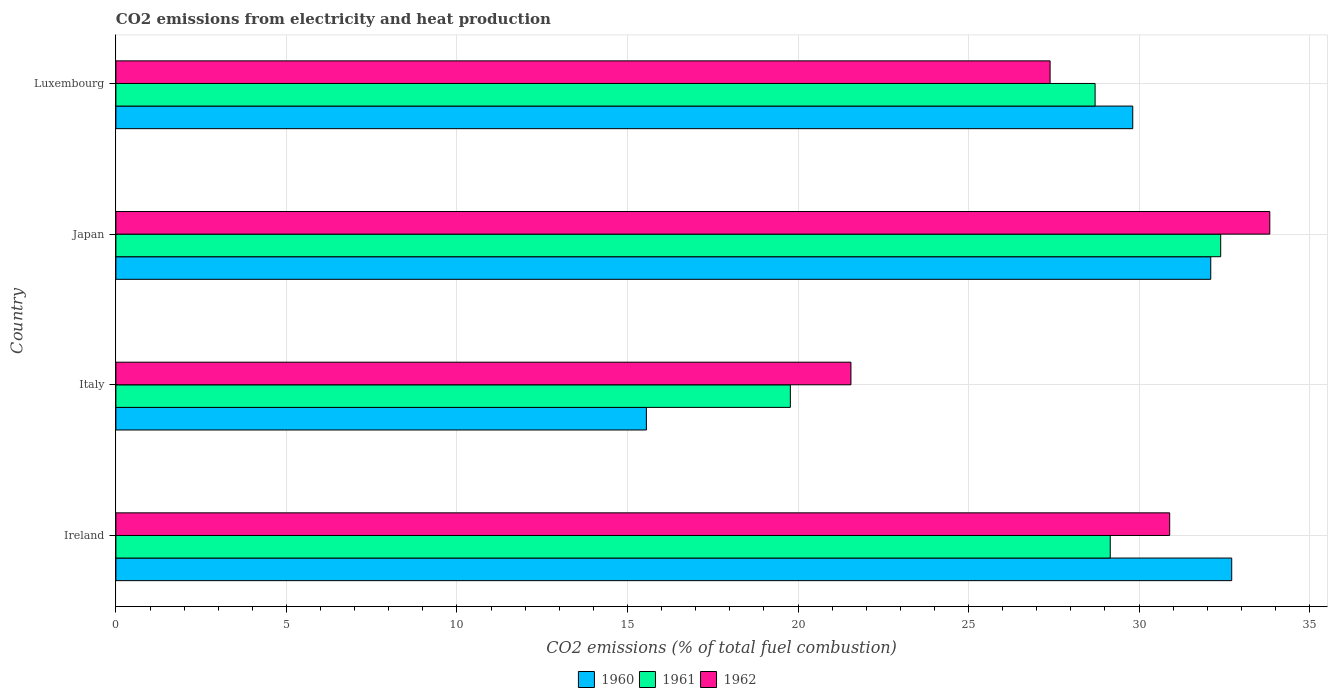How many different coloured bars are there?
Provide a succinct answer. 3. How many groups of bars are there?
Provide a succinct answer. 4. How many bars are there on the 4th tick from the top?
Offer a very short reply. 3. How many bars are there on the 1st tick from the bottom?
Provide a succinct answer. 3. In how many cases, is the number of bars for a given country not equal to the number of legend labels?
Offer a terse response. 0. What is the amount of CO2 emitted in 1961 in Italy?
Your response must be concise. 19.78. Across all countries, what is the maximum amount of CO2 emitted in 1960?
Provide a short and direct response. 32.72. Across all countries, what is the minimum amount of CO2 emitted in 1962?
Your response must be concise. 21.55. In which country was the amount of CO2 emitted in 1961 maximum?
Keep it short and to the point. Japan. In which country was the amount of CO2 emitted in 1960 minimum?
Make the answer very short. Italy. What is the total amount of CO2 emitted in 1962 in the graph?
Your response must be concise. 113.67. What is the difference between the amount of CO2 emitted in 1962 in Italy and that in Japan?
Provide a succinct answer. -12.28. What is the difference between the amount of CO2 emitted in 1961 in Luxembourg and the amount of CO2 emitted in 1960 in Ireland?
Offer a terse response. -4.01. What is the average amount of CO2 emitted in 1961 per country?
Your answer should be very brief. 27.51. What is the difference between the amount of CO2 emitted in 1961 and amount of CO2 emitted in 1962 in Japan?
Ensure brevity in your answer.  -1.44. In how many countries, is the amount of CO2 emitted in 1961 greater than 21 %?
Offer a terse response. 3. What is the ratio of the amount of CO2 emitted in 1961 in Ireland to that in Luxembourg?
Provide a short and direct response. 1.02. Is the difference between the amount of CO2 emitted in 1961 in Ireland and Italy greater than the difference between the amount of CO2 emitted in 1962 in Ireland and Italy?
Make the answer very short. Yes. What is the difference between the highest and the second highest amount of CO2 emitted in 1962?
Offer a terse response. 2.94. What is the difference between the highest and the lowest amount of CO2 emitted in 1961?
Provide a succinct answer. 12.62. Is the sum of the amount of CO2 emitted in 1961 in Japan and Luxembourg greater than the maximum amount of CO2 emitted in 1962 across all countries?
Your answer should be compact. Yes. What does the 2nd bar from the top in Japan represents?
Your answer should be compact. 1961. What does the 2nd bar from the bottom in Ireland represents?
Ensure brevity in your answer.  1961. Are all the bars in the graph horizontal?
Provide a succinct answer. Yes. How many countries are there in the graph?
Make the answer very short. 4. What is the difference between two consecutive major ticks on the X-axis?
Ensure brevity in your answer.  5. Does the graph contain any zero values?
Your response must be concise. No. Where does the legend appear in the graph?
Your response must be concise. Bottom center. What is the title of the graph?
Offer a terse response. CO2 emissions from electricity and heat production. What is the label or title of the X-axis?
Offer a very short reply. CO2 emissions (% of total fuel combustion). What is the CO2 emissions (% of total fuel combustion) of 1960 in Ireland?
Offer a very short reply. 32.72. What is the CO2 emissions (% of total fuel combustion) of 1961 in Ireland?
Your response must be concise. 29.15. What is the CO2 emissions (% of total fuel combustion) in 1962 in Ireland?
Ensure brevity in your answer.  30.9. What is the CO2 emissions (% of total fuel combustion) in 1960 in Italy?
Offer a terse response. 15.55. What is the CO2 emissions (% of total fuel combustion) of 1961 in Italy?
Provide a succinct answer. 19.78. What is the CO2 emissions (% of total fuel combustion) of 1962 in Italy?
Provide a short and direct response. 21.55. What is the CO2 emissions (% of total fuel combustion) in 1960 in Japan?
Offer a terse response. 32.1. What is the CO2 emissions (% of total fuel combustion) in 1961 in Japan?
Give a very brief answer. 32.39. What is the CO2 emissions (% of total fuel combustion) in 1962 in Japan?
Give a very brief answer. 33.83. What is the CO2 emissions (% of total fuel combustion) of 1960 in Luxembourg?
Make the answer very short. 29.81. What is the CO2 emissions (% of total fuel combustion) in 1961 in Luxembourg?
Ensure brevity in your answer.  28.71. What is the CO2 emissions (% of total fuel combustion) of 1962 in Luxembourg?
Give a very brief answer. 27.39. Across all countries, what is the maximum CO2 emissions (% of total fuel combustion) in 1960?
Offer a very short reply. 32.72. Across all countries, what is the maximum CO2 emissions (% of total fuel combustion) in 1961?
Provide a succinct answer. 32.39. Across all countries, what is the maximum CO2 emissions (% of total fuel combustion) in 1962?
Offer a very short reply. 33.83. Across all countries, what is the minimum CO2 emissions (% of total fuel combustion) in 1960?
Make the answer very short. 15.55. Across all countries, what is the minimum CO2 emissions (% of total fuel combustion) of 1961?
Your response must be concise. 19.78. Across all countries, what is the minimum CO2 emissions (% of total fuel combustion) of 1962?
Offer a very short reply. 21.55. What is the total CO2 emissions (% of total fuel combustion) in 1960 in the graph?
Your response must be concise. 110.19. What is the total CO2 emissions (% of total fuel combustion) in 1961 in the graph?
Your answer should be compact. 110.03. What is the total CO2 emissions (% of total fuel combustion) of 1962 in the graph?
Keep it short and to the point. 113.67. What is the difference between the CO2 emissions (% of total fuel combustion) of 1960 in Ireland and that in Italy?
Make the answer very short. 17.16. What is the difference between the CO2 emissions (% of total fuel combustion) in 1961 in Ireland and that in Italy?
Give a very brief answer. 9.38. What is the difference between the CO2 emissions (% of total fuel combustion) of 1962 in Ireland and that in Italy?
Offer a very short reply. 9.35. What is the difference between the CO2 emissions (% of total fuel combustion) in 1960 in Ireland and that in Japan?
Make the answer very short. 0.61. What is the difference between the CO2 emissions (% of total fuel combustion) in 1961 in Ireland and that in Japan?
Ensure brevity in your answer.  -3.24. What is the difference between the CO2 emissions (% of total fuel combustion) in 1962 in Ireland and that in Japan?
Offer a terse response. -2.94. What is the difference between the CO2 emissions (% of total fuel combustion) in 1960 in Ireland and that in Luxembourg?
Provide a short and direct response. 2.9. What is the difference between the CO2 emissions (% of total fuel combustion) in 1961 in Ireland and that in Luxembourg?
Provide a succinct answer. 0.44. What is the difference between the CO2 emissions (% of total fuel combustion) in 1962 in Ireland and that in Luxembourg?
Your response must be concise. 3.51. What is the difference between the CO2 emissions (% of total fuel combustion) in 1960 in Italy and that in Japan?
Your response must be concise. -16.55. What is the difference between the CO2 emissions (% of total fuel combustion) of 1961 in Italy and that in Japan?
Your response must be concise. -12.62. What is the difference between the CO2 emissions (% of total fuel combustion) in 1962 in Italy and that in Japan?
Keep it short and to the point. -12.28. What is the difference between the CO2 emissions (% of total fuel combustion) in 1960 in Italy and that in Luxembourg?
Give a very brief answer. -14.26. What is the difference between the CO2 emissions (% of total fuel combustion) in 1961 in Italy and that in Luxembourg?
Make the answer very short. -8.93. What is the difference between the CO2 emissions (% of total fuel combustion) of 1962 in Italy and that in Luxembourg?
Offer a terse response. -5.84. What is the difference between the CO2 emissions (% of total fuel combustion) of 1960 in Japan and that in Luxembourg?
Provide a short and direct response. 2.29. What is the difference between the CO2 emissions (% of total fuel combustion) of 1961 in Japan and that in Luxembourg?
Provide a succinct answer. 3.68. What is the difference between the CO2 emissions (% of total fuel combustion) in 1962 in Japan and that in Luxembourg?
Provide a short and direct response. 6.44. What is the difference between the CO2 emissions (% of total fuel combustion) of 1960 in Ireland and the CO2 emissions (% of total fuel combustion) of 1961 in Italy?
Your answer should be very brief. 12.94. What is the difference between the CO2 emissions (% of total fuel combustion) in 1960 in Ireland and the CO2 emissions (% of total fuel combustion) in 1962 in Italy?
Offer a terse response. 11.16. What is the difference between the CO2 emissions (% of total fuel combustion) in 1961 in Ireland and the CO2 emissions (% of total fuel combustion) in 1962 in Italy?
Give a very brief answer. 7.6. What is the difference between the CO2 emissions (% of total fuel combustion) of 1960 in Ireland and the CO2 emissions (% of total fuel combustion) of 1961 in Japan?
Your response must be concise. 0.32. What is the difference between the CO2 emissions (% of total fuel combustion) of 1960 in Ireland and the CO2 emissions (% of total fuel combustion) of 1962 in Japan?
Your answer should be compact. -1.12. What is the difference between the CO2 emissions (% of total fuel combustion) in 1961 in Ireland and the CO2 emissions (% of total fuel combustion) in 1962 in Japan?
Make the answer very short. -4.68. What is the difference between the CO2 emissions (% of total fuel combustion) in 1960 in Ireland and the CO2 emissions (% of total fuel combustion) in 1961 in Luxembourg?
Your answer should be compact. 4.01. What is the difference between the CO2 emissions (% of total fuel combustion) of 1960 in Ireland and the CO2 emissions (% of total fuel combustion) of 1962 in Luxembourg?
Offer a terse response. 5.33. What is the difference between the CO2 emissions (% of total fuel combustion) of 1961 in Ireland and the CO2 emissions (% of total fuel combustion) of 1962 in Luxembourg?
Offer a very short reply. 1.76. What is the difference between the CO2 emissions (% of total fuel combustion) of 1960 in Italy and the CO2 emissions (% of total fuel combustion) of 1961 in Japan?
Make the answer very short. -16.84. What is the difference between the CO2 emissions (% of total fuel combustion) of 1960 in Italy and the CO2 emissions (% of total fuel combustion) of 1962 in Japan?
Offer a terse response. -18.28. What is the difference between the CO2 emissions (% of total fuel combustion) of 1961 in Italy and the CO2 emissions (% of total fuel combustion) of 1962 in Japan?
Offer a terse response. -14.06. What is the difference between the CO2 emissions (% of total fuel combustion) of 1960 in Italy and the CO2 emissions (% of total fuel combustion) of 1961 in Luxembourg?
Give a very brief answer. -13.16. What is the difference between the CO2 emissions (% of total fuel combustion) of 1960 in Italy and the CO2 emissions (% of total fuel combustion) of 1962 in Luxembourg?
Offer a terse response. -11.84. What is the difference between the CO2 emissions (% of total fuel combustion) in 1961 in Italy and the CO2 emissions (% of total fuel combustion) in 1962 in Luxembourg?
Provide a short and direct response. -7.62. What is the difference between the CO2 emissions (% of total fuel combustion) in 1960 in Japan and the CO2 emissions (% of total fuel combustion) in 1961 in Luxembourg?
Your answer should be compact. 3.39. What is the difference between the CO2 emissions (% of total fuel combustion) of 1960 in Japan and the CO2 emissions (% of total fuel combustion) of 1962 in Luxembourg?
Your response must be concise. 4.71. What is the difference between the CO2 emissions (% of total fuel combustion) in 1961 in Japan and the CO2 emissions (% of total fuel combustion) in 1962 in Luxembourg?
Make the answer very short. 5. What is the average CO2 emissions (% of total fuel combustion) in 1960 per country?
Provide a short and direct response. 27.55. What is the average CO2 emissions (% of total fuel combustion) in 1961 per country?
Your answer should be very brief. 27.51. What is the average CO2 emissions (% of total fuel combustion) in 1962 per country?
Ensure brevity in your answer.  28.42. What is the difference between the CO2 emissions (% of total fuel combustion) in 1960 and CO2 emissions (% of total fuel combustion) in 1961 in Ireland?
Provide a short and direct response. 3.56. What is the difference between the CO2 emissions (% of total fuel combustion) in 1960 and CO2 emissions (% of total fuel combustion) in 1962 in Ireland?
Your answer should be compact. 1.82. What is the difference between the CO2 emissions (% of total fuel combustion) in 1961 and CO2 emissions (% of total fuel combustion) in 1962 in Ireland?
Provide a succinct answer. -1.74. What is the difference between the CO2 emissions (% of total fuel combustion) of 1960 and CO2 emissions (% of total fuel combustion) of 1961 in Italy?
Your answer should be very brief. -4.22. What is the difference between the CO2 emissions (% of total fuel combustion) in 1960 and CO2 emissions (% of total fuel combustion) in 1962 in Italy?
Keep it short and to the point. -6. What is the difference between the CO2 emissions (% of total fuel combustion) in 1961 and CO2 emissions (% of total fuel combustion) in 1962 in Italy?
Offer a terse response. -1.78. What is the difference between the CO2 emissions (% of total fuel combustion) of 1960 and CO2 emissions (% of total fuel combustion) of 1961 in Japan?
Provide a short and direct response. -0.29. What is the difference between the CO2 emissions (% of total fuel combustion) in 1960 and CO2 emissions (% of total fuel combustion) in 1962 in Japan?
Your response must be concise. -1.73. What is the difference between the CO2 emissions (% of total fuel combustion) of 1961 and CO2 emissions (% of total fuel combustion) of 1962 in Japan?
Offer a very short reply. -1.44. What is the difference between the CO2 emissions (% of total fuel combustion) in 1960 and CO2 emissions (% of total fuel combustion) in 1961 in Luxembourg?
Your response must be concise. 1.1. What is the difference between the CO2 emissions (% of total fuel combustion) in 1960 and CO2 emissions (% of total fuel combustion) in 1962 in Luxembourg?
Your answer should be compact. 2.42. What is the difference between the CO2 emissions (% of total fuel combustion) in 1961 and CO2 emissions (% of total fuel combustion) in 1962 in Luxembourg?
Offer a terse response. 1.32. What is the ratio of the CO2 emissions (% of total fuel combustion) of 1960 in Ireland to that in Italy?
Ensure brevity in your answer.  2.1. What is the ratio of the CO2 emissions (% of total fuel combustion) of 1961 in Ireland to that in Italy?
Give a very brief answer. 1.47. What is the ratio of the CO2 emissions (% of total fuel combustion) of 1962 in Ireland to that in Italy?
Your answer should be compact. 1.43. What is the ratio of the CO2 emissions (% of total fuel combustion) of 1960 in Ireland to that in Japan?
Make the answer very short. 1.02. What is the ratio of the CO2 emissions (% of total fuel combustion) of 1962 in Ireland to that in Japan?
Your response must be concise. 0.91. What is the ratio of the CO2 emissions (% of total fuel combustion) of 1960 in Ireland to that in Luxembourg?
Make the answer very short. 1.1. What is the ratio of the CO2 emissions (% of total fuel combustion) in 1961 in Ireland to that in Luxembourg?
Your answer should be very brief. 1.02. What is the ratio of the CO2 emissions (% of total fuel combustion) in 1962 in Ireland to that in Luxembourg?
Provide a short and direct response. 1.13. What is the ratio of the CO2 emissions (% of total fuel combustion) in 1960 in Italy to that in Japan?
Ensure brevity in your answer.  0.48. What is the ratio of the CO2 emissions (% of total fuel combustion) of 1961 in Italy to that in Japan?
Ensure brevity in your answer.  0.61. What is the ratio of the CO2 emissions (% of total fuel combustion) of 1962 in Italy to that in Japan?
Your response must be concise. 0.64. What is the ratio of the CO2 emissions (% of total fuel combustion) in 1960 in Italy to that in Luxembourg?
Provide a succinct answer. 0.52. What is the ratio of the CO2 emissions (% of total fuel combustion) of 1961 in Italy to that in Luxembourg?
Provide a succinct answer. 0.69. What is the ratio of the CO2 emissions (% of total fuel combustion) in 1962 in Italy to that in Luxembourg?
Keep it short and to the point. 0.79. What is the ratio of the CO2 emissions (% of total fuel combustion) of 1960 in Japan to that in Luxembourg?
Your response must be concise. 1.08. What is the ratio of the CO2 emissions (% of total fuel combustion) in 1961 in Japan to that in Luxembourg?
Make the answer very short. 1.13. What is the ratio of the CO2 emissions (% of total fuel combustion) of 1962 in Japan to that in Luxembourg?
Ensure brevity in your answer.  1.24. What is the difference between the highest and the second highest CO2 emissions (% of total fuel combustion) in 1960?
Offer a terse response. 0.61. What is the difference between the highest and the second highest CO2 emissions (% of total fuel combustion) of 1961?
Offer a very short reply. 3.24. What is the difference between the highest and the second highest CO2 emissions (% of total fuel combustion) of 1962?
Offer a terse response. 2.94. What is the difference between the highest and the lowest CO2 emissions (% of total fuel combustion) of 1960?
Ensure brevity in your answer.  17.16. What is the difference between the highest and the lowest CO2 emissions (% of total fuel combustion) in 1961?
Provide a short and direct response. 12.62. What is the difference between the highest and the lowest CO2 emissions (% of total fuel combustion) of 1962?
Keep it short and to the point. 12.28. 